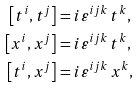Convert formula to latex. <formula><loc_0><loc_0><loc_500><loc_500>\left [ t ^ { i } , t ^ { j } \right ] & = i \varepsilon ^ { i j k } \, t ^ { k } , \\ \left [ x ^ { i } , x ^ { j } \right ] & = i \varepsilon ^ { i j k } \, t ^ { k } , \\ \left [ t ^ { i } , x ^ { j } \right ] & = i \varepsilon ^ { i j k } \, x ^ { k } ,</formula> 